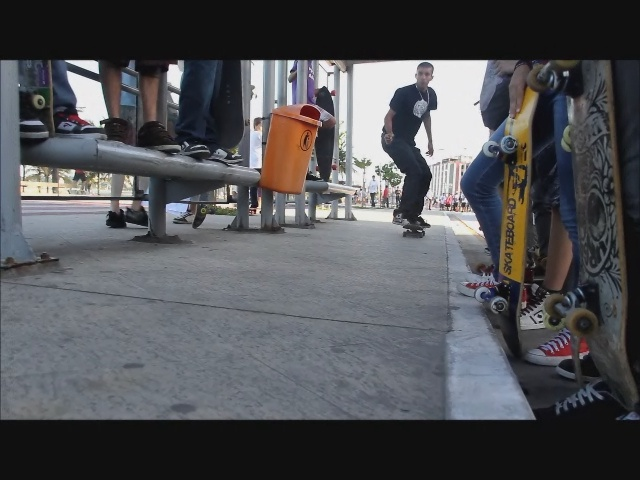Describe the objects in this image and their specific colors. I can see people in black, gray, and lightgray tones, skateboard in black and gray tones, bench in black, gray, and darkgray tones, skateboard in black, olive, and gray tones, and people in black, gray, and darkgray tones in this image. 